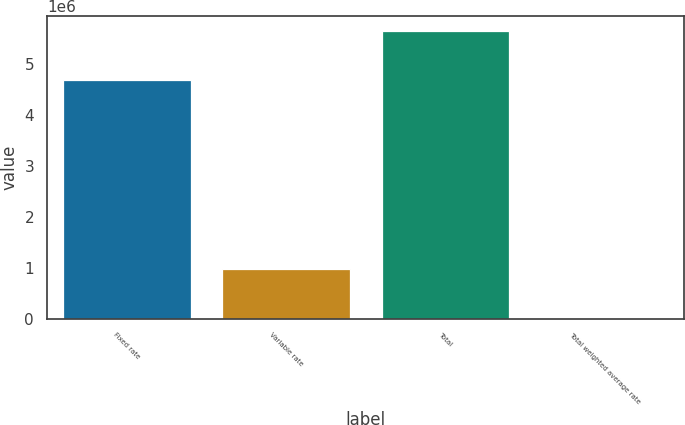Convert chart to OTSL. <chart><loc_0><loc_0><loc_500><loc_500><bar_chart><fcel>Fixed rate<fcel>Variable rate<fcel>Total<fcel>Total weighted average rate<nl><fcel>4.69508e+06<fcel>972427<fcel>5.66751e+06<fcel>5.65<nl></chart> 